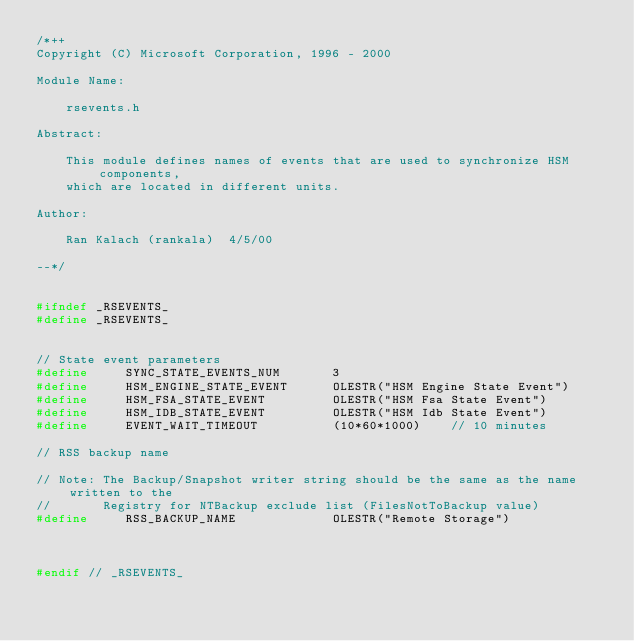<code> <loc_0><loc_0><loc_500><loc_500><_C_>/*++
Copyright (C) Microsoft Corporation, 1996 - 2000

Module Name:

    rsevents.h

Abstract:

    This module defines names of events that are used to synchronize HSM components,
    which are located in different units.

Author:

    Ran Kalach (rankala)  4/5/00

--*/


#ifndef _RSEVENTS_
#define _RSEVENTS_


// State event parameters
#define     SYNC_STATE_EVENTS_NUM       3
#define     HSM_ENGINE_STATE_EVENT      OLESTR("HSM Engine State Event")
#define     HSM_FSA_STATE_EVENT         OLESTR("HSM Fsa State Event")
#define     HSM_IDB_STATE_EVENT         OLESTR("HSM Idb State Event")
#define     EVENT_WAIT_TIMEOUT          (10*60*1000)    // 10 minutes

// RSS backup name

// Note: The Backup/Snapshot writer string should be the same as the name written to the 
//       Registry for NTBackup exclude list (FilesNotToBackup value)
#define     RSS_BACKUP_NAME             OLESTR("Remote Storage")



#endif // _RSEVENTS_
</code> 